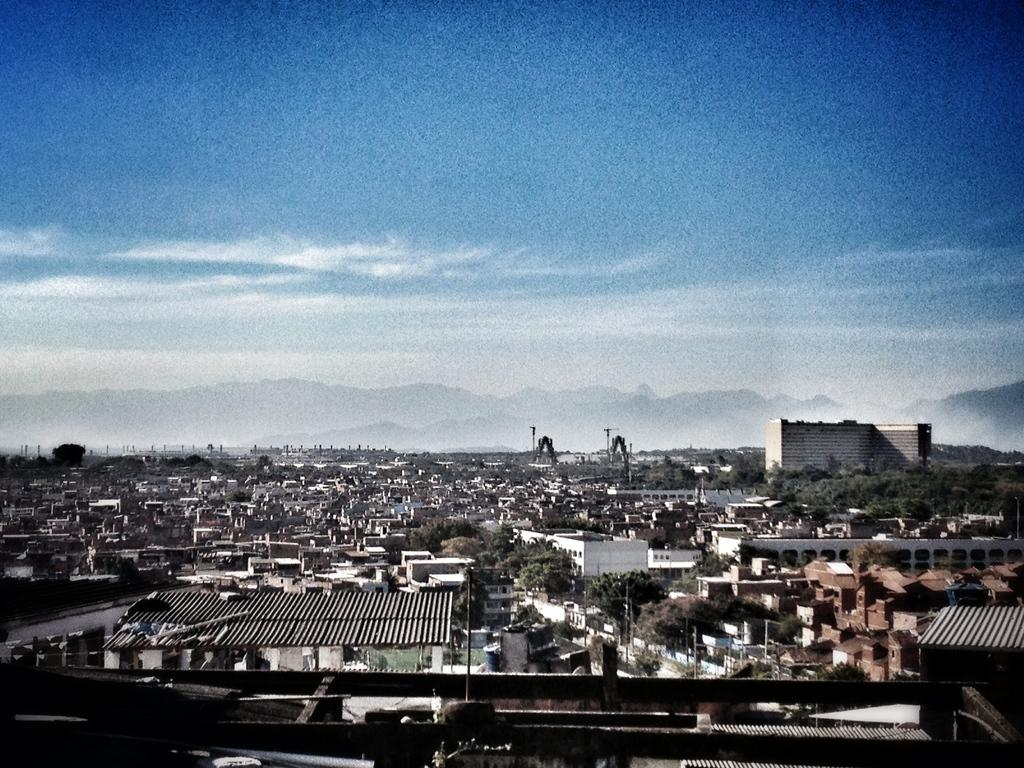Where was the picture taken? The picture was clicked outside the city. What can be seen in the foreground of the image? There are many buildings and houses, as well as trees visible in the foreground. What is visible in the background of the image? The sky is visible in the background. Can you see a zephyr blowing through the trees in the image? There is no mention of a zephyr in the image, and it is not possible to determine the presence of wind based on the provided facts. 